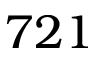Convert formula to latex. <formula><loc_0><loc_0><loc_500><loc_500>7 2 1</formula> 